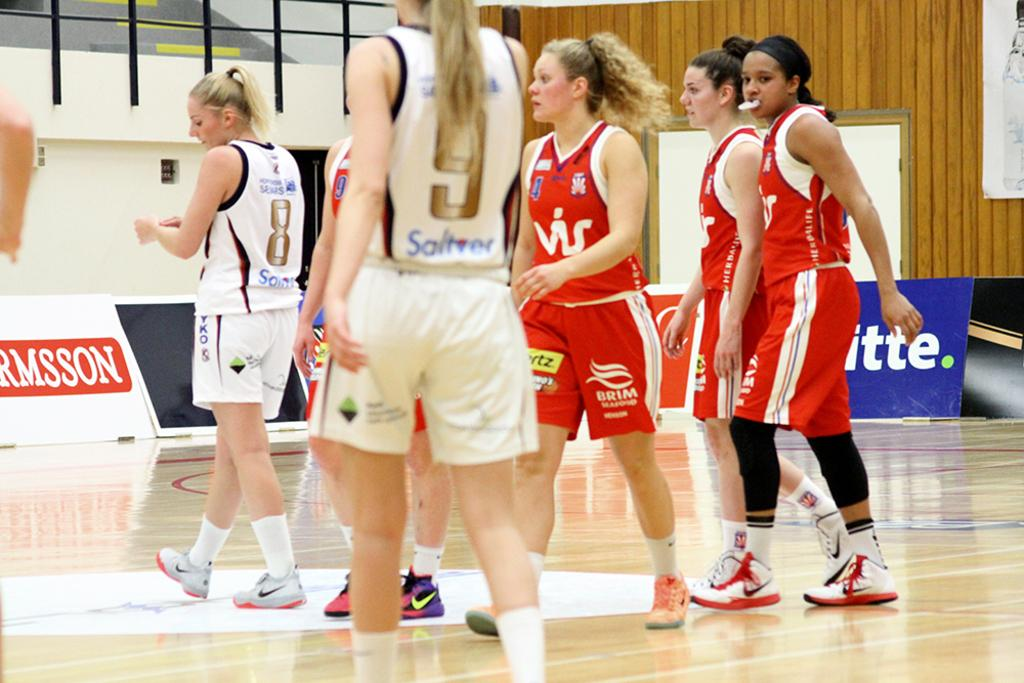<image>
Create a compact narrative representing the image presented. Players wear jerseys on a court, including one with the number 8. 